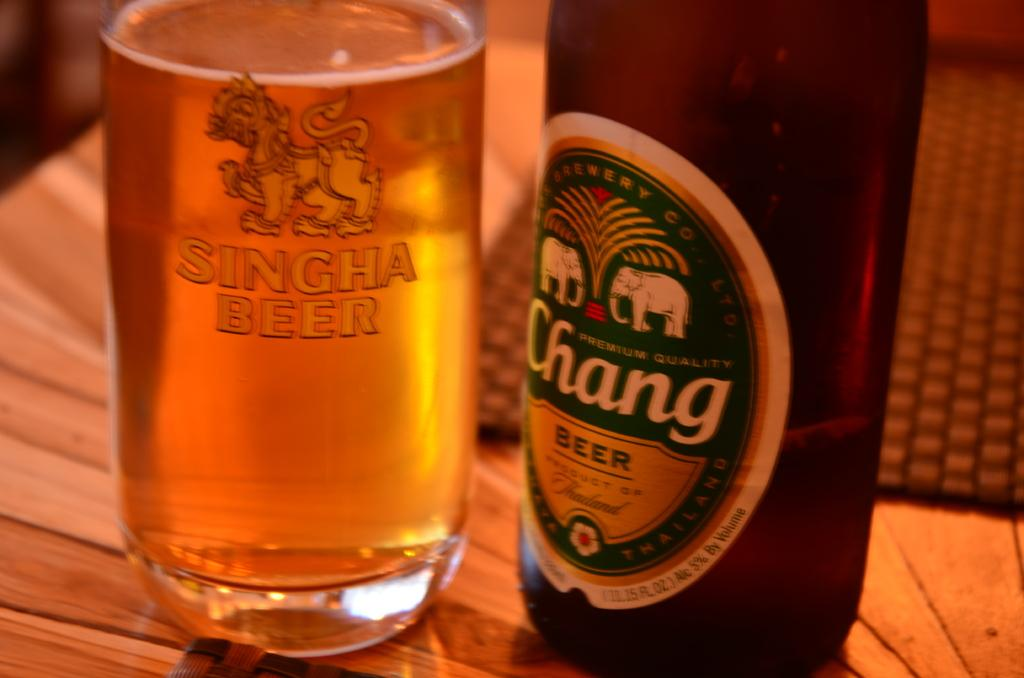<image>
Offer a succinct explanation of the picture presented. A bottle of Chang Beer with elephants on the bottle, and a glass filled with Chang beer. 